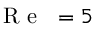<formula> <loc_0><loc_0><loc_500><loc_500>{ R e } = 5</formula> 